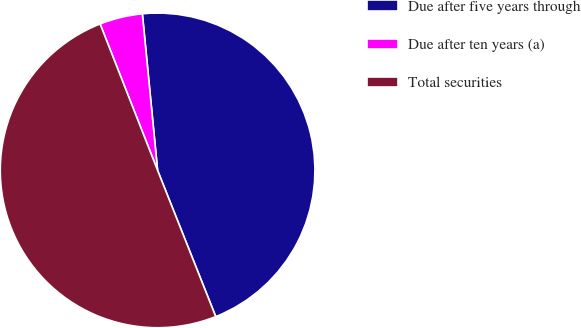Convert chart to OTSL. <chart><loc_0><loc_0><loc_500><loc_500><pie_chart><fcel>Due after five years through<fcel>Due after ten years (a)<fcel>Total securities<nl><fcel>45.52%<fcel>4.41%<fcel>50.07%<nl></chart> 